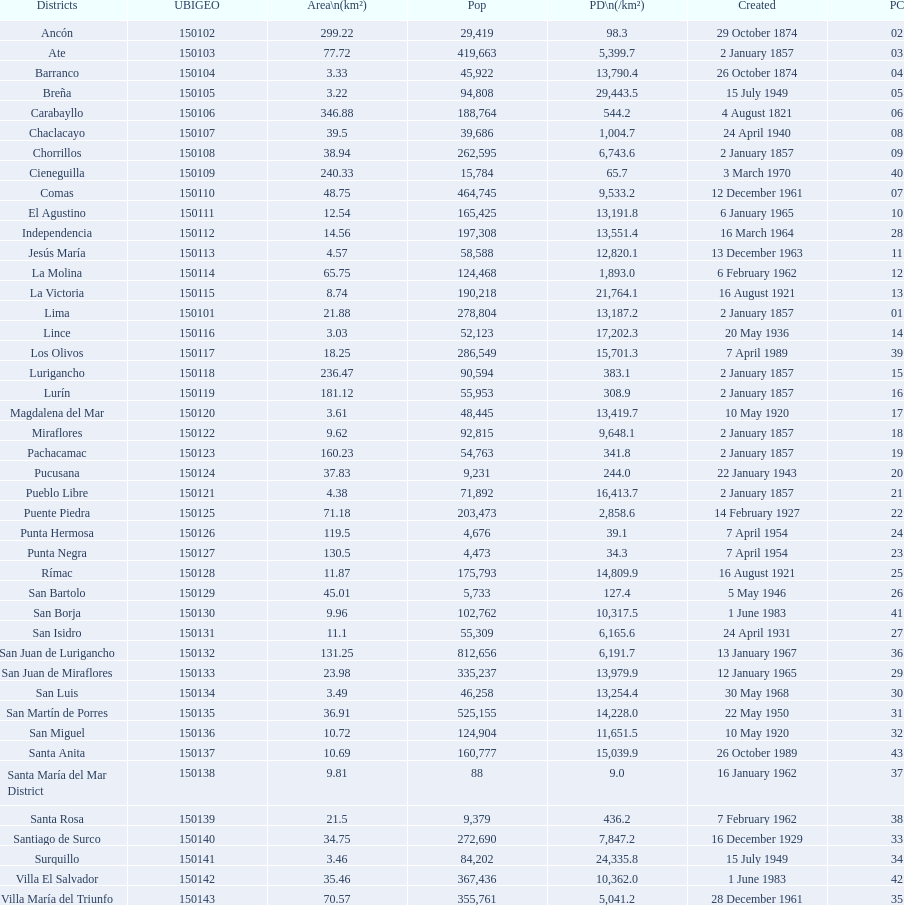What was the last district created? Santa Anita. 